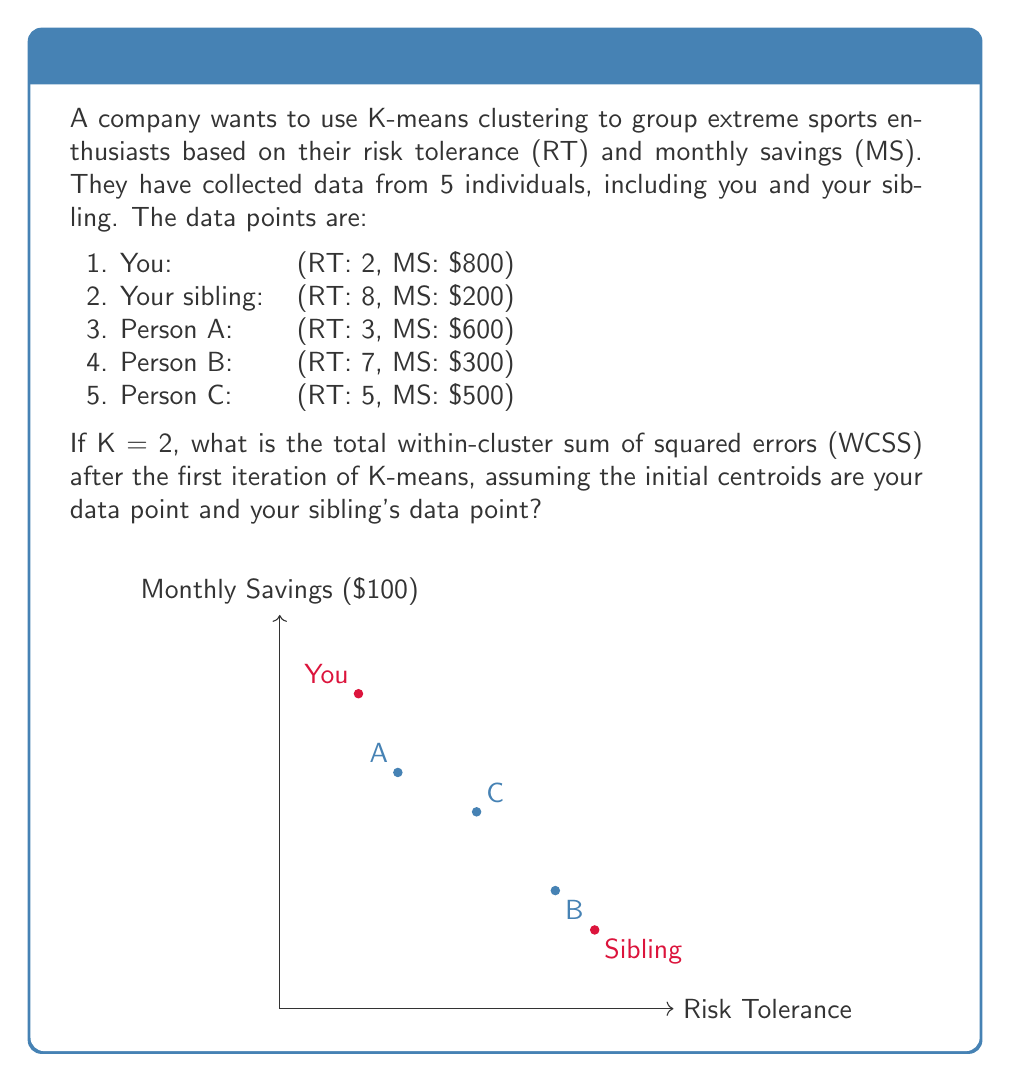Could you help me with this problem? Let's solve this step-by-step:

1) First, we need to assign each point to the nearest centroid. The initial centroids are:
   Centroid 1 (C1): (2, 8) - Your data point
   Centroid 2 (C2): (8, 2) - Your sibling's data point

2) To find the nearest centroid for each point, we calculate the Euclidean distance between the point and each centroid:

   For point A (3, 6):
   Distance to C1 = $\sqrt{(3-2)^2 + (6-8)^2} = \sqrt{5} \approx 2.24$
   Distance to C2 = $\sqrt{(3-8)^2 + (6-2)^2} = \sqrt{61} \approx 7.81$
   A is closer to C1

   For point B (7, 3):
   Distance to C1 = $\sqrt{(7-2)^2 + (3-8)^2} = \sqrt{74} \approx 8.60$
   Distance to C2 = $\sqrt{(7-8)^2 + (3-2)^2} = \sqrt{2} \approx 1.41$
   B is closer to C2

   For point C (5, 5):
   Distance to C1 = $\sqrt{(5-2)^2 + (5-8)^2} = \sqrt{34} \approx 5.83$
   Distance to C2 = $\sqrt{(5-8)^2 + (5-2)^2} = \sqrt{18} \approx 4.24$
   C is closer to C2

3) Now we have two clusters:
   Cluster 1: {You, A}
   Cluster 2: {Your sibling, B, C}

4) The WCSS is calculated by summing the squared distances of each point to its assigned centroid:

   For Cluster 1:
   You: $(2-2)^2 + (8-8)^2 = 0$
   A: $(3-2)^2 + (6-8)^2 = 5$

   For Cluster 2:
   Your sibling: $(8-8)^2 + (2-2)^2 = 0$
   B: $(7-8)^2 + (3-2)^2 = 2$
   C: $(5-8)^2 + (5-2)^2 = 18$

5) Total WCSS = $0 + 5 + 0 + 2 + 18 = 25$
Answer: 25 